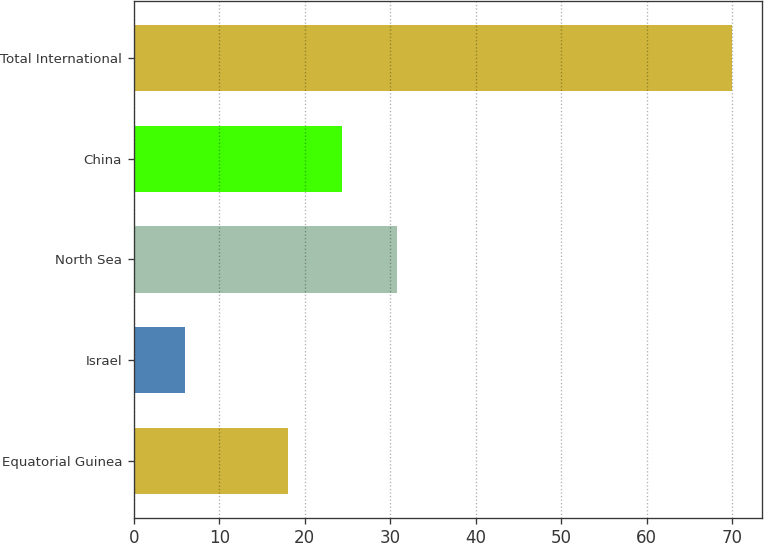<chart> <loc_0><loc_0><loc_500><loc_500><bar_chart><fcel>Equatorial Guinea<fcel>Israel<fcel>North Sea<fcel>China<fcel>Total International<nl><fcel>18<fcel>6<fcel>30.8<fcel>24.4<fcel>70<nl></chart> 